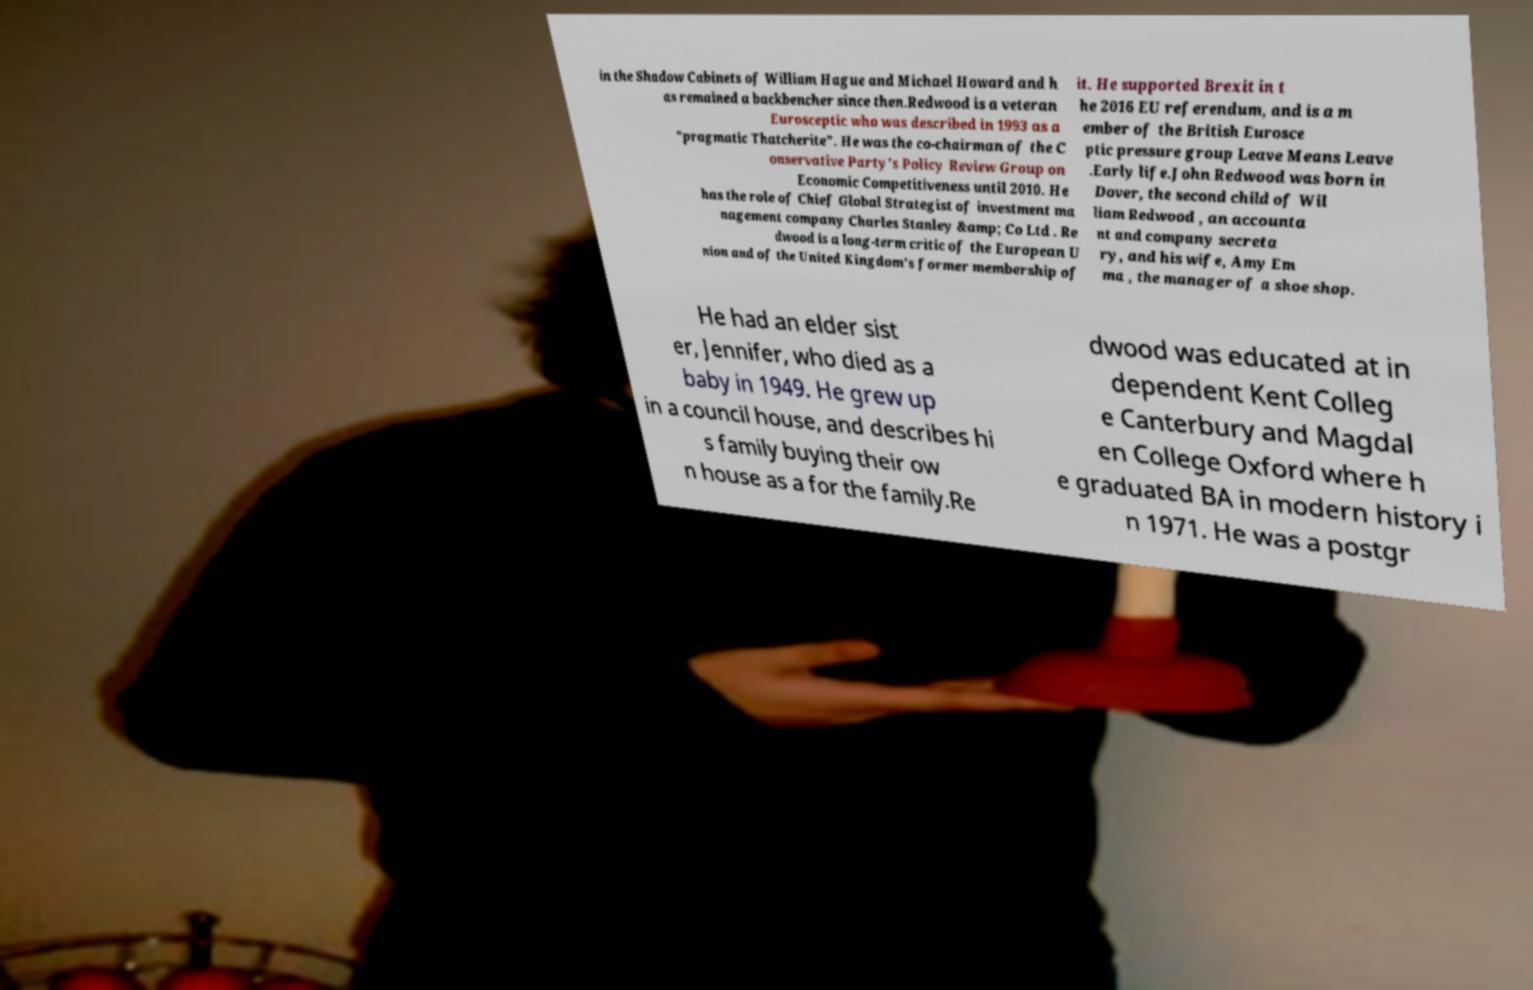Could you assist in decoding the text presented in this image and type it out clearly? in the Shadow Cabinets of William Hague and Michael Howard and h as remained a backbencher since then.Redwood is a veteran Eurosceptic who was described in 1993 as a "pragmatic Thatcherite". He was the co-chairman of the C onservative Party's Policy Review Group on Economic Competitiveness until 2010. He has the role of Chief Global Strategist of investment ma nagement company Charles Stanley &amp; Co Ltd . Re dwood is a long-term critic of the European U nion and of the United Kingdom's former membership of it. He supported Brexit in t he 2016 EU referendum, and is a m ember of the British Eurosce ptic pressure group Leave Means Leave .Early life.John Redwood was born in Dover, the second child of Wil liam Redwood , an accounta nt and company secreta ry, and his wife, Amy Em ma , the manager of a shoe shop. He had an elder sist er, Jennifer, who died as a baby in 1949. He grew up in a council house, and describes hi s family buying their ow n house as a for the family.Re dwood was educated at in dependent Kent Colleg e Canterbury and Magdal en College Oxford where h e graduated BA in modern history i n 1971. He was a postgr 